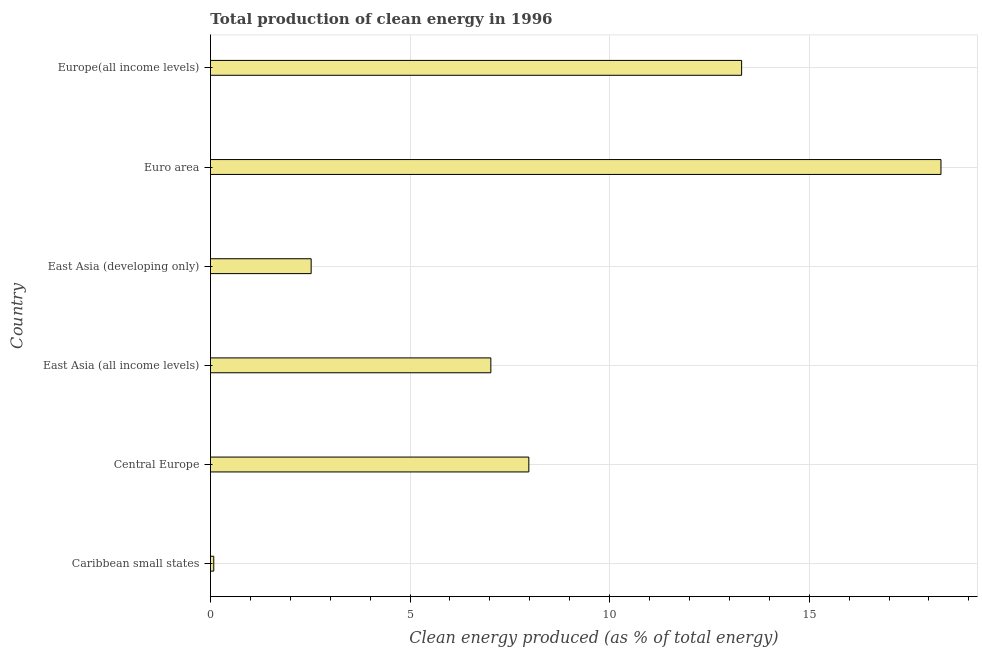Does the graph contain grids?
Offer a terse response. Yes. What is the title of the graph?
Provide a succinct answer. Total production of clean energy in 1996. What is the label or title of the X-axis?
Ensure brevity in your answer.  Clean energy produced (as % of total energy). What is the label or title of the Y-axis?
Provide a succinct answer. Country. What is the production of clean energy in East Asia (all income levels)?
Give a very brief answer. 7.02. Across all countries, what is the maximum production of clean energy?
Your answer should be compact. 18.3. Across all countries, what is the minimum production of clean energy?
Make the answer very short. 0.08. In which country was the production of clean energy maximum?
Give a very brief answer. Euro area. In which country was the production of clean energy minimum?
Offer a very short reply. Caribbean small states. What is the sum of the production of clean energy?
Your answer should be compact. 49.21. What is the difference between the production of clean energy in Caribbean small states and East Asia (developing only)?
Your response must be concise. -2.44. What is the average production of clean energy per country?
Provide a short and direct response. 8.2. What is the median production of clean energy?
Provide a short and direct response. 7.5. What is the ratio of the production of clean energy in Caribbean small states to that in East Asia (all income levels)?
Provide a short and direct response. 0.01. Is the difference between the production of clean energy in East Asia (all income levels) and East Asia (developing only) greater than the difference between any two countries?
Make the answer very short. No. What is the difference between the highest and the second highest production of clean energy?
Make the answer very short. 4.99. Is the sum of the production of clean energy in Central Europe and East Asia (developing only) greater than the maximum production of clean energy across all countries?
Keep it short and to the point. No. What is the difference between the highest and the lowest production of clean energy?
Make the answer very short. 18.22. In how many countries, is the production of clean energy greater than the average production of clean energy taken over all countries?
Your answer should be very brief. 2. How many bars are there?
Keep it short and to the point. 6. Are the values on the major ticks of X-axis written in scientific E-notation?
Your answer should be compact. No. What is the Clean energy produced (as % of total energy) of Caribbean small states?
Give a very brief answer. 0.08. What is the Clean energy produced (as % of total energy) in Central Europe?
Make the answer very short. 7.98. What is the Clean energy produced (as % of total energy) in East Asia (all income levels)?
Your answer should be very brief. 7.02. What is the Clean energy produced (as % of total energy) of East Asia (developing only)?
Give a very brief answer. 2.52. What is the Clean energy produced (as % of total energy) of Euro area?
Provide a short and direct response. 18.3. What is the Clean energy produced (as % of total energy) in Europe(all income levels)?
Make the answer very short. 13.31. What is the difference between the Clean energy produced (as % of total energy) in Caribbean small states and Central Europe?
Make the answer very short. -7.89. What is the difference between the Clean energy produced (as % of total energy) in Caribbean small states and East Asia (all income levels)?
Your answer should be very brief. -6.94. What is the difference between the Clean energy produced (as % of total energy) in Caribbean small states and East Asia (developing only)?
Offer a terse response. -2.44. What is the difference between the Clean energy produced (as % of total energy) in Caribbean small states and Euro area?
Keep it short and to the point. -18.22. What is the difference between the Clean energy produced (as % of total energy) in Caribbean small states and Europe(all income levels)?
Your response must be concise. -13.22. What is the difference between the Clean energy produced (as % of total energy) in Central Europe and East Asia (all income levels)?
Ensure brevity in your answer.  0.95. What is the difference between the Clean energy produced (as % of total energy) in Central Europe and East Asia (developing only)?
Keep it short and to the point. 5.45. What is the difference between the Clean energy produced (as % of total energy) in Central Europe and Euro area?
Make the answer very short. -10.33. What is the difference between the Clean energy produced (as % of total energy) in Central Europe and Europe(all income levels)?
Offer a terse response. -5.33. What is the difference between the Clean energy produced (as % of total energy) in East Asia (all income levels) and East Asia (developing only)?
Your answer should be compact. 4.5. What is the difference between the Clean energy produced (as % of total energy) in East Asia (all income levels) and Euro area?
Your response must be concise. -11.28. What is the difference between the Clean energy produced (as % of total energy) in East Asia (all income levels) and Europe(all income levels)?
Your response must be concise. -6.28. What is the difference between the Clean energy produced (as % of total energy) in East Asia (developing only) and Euro area?
Your answer should be very brief. -15.78. What is the difference between the Clean energy produced (as % of total energy) in East Asia (developing only) and Europe(all income levels)?
Provide a short and direct response. -10.78. What is the difference between the Clean energy produced (as % of total energy) in Euro area and Europe(all income levels)?
Keep it short and to the point. 4.99. What is the ratio of the Clean energy produced (as % of total energy) in Caribbean small states to that in East Asia (all income levels)?
Provide a succinct answer. 0.01. What is the ratio of the Clean energy produced (as % of total energy) in Caribbean small states to that in East Asia (developing only)?
Ensure brevity in your answer.  0.03. What is the ratio of the Clean energy produced (as % of total energy) in Caribbean small states to that in Euro area?
Keep it short and to the point. 0.01. What is the ratio of the Clean energy produced (as % of total energy) in Caribbean small states to that in Europe(all income levels)?
Give a very brief answer. 0.01. What is the ratio of the Clean energy produced (as % of total energy) in Central Europe to that in East Asia (all income levels)?
Provide a succinct answer. 1.14. What is the ratio of the Clean energy produced (as % of total energy) in Central Europe to that in East Asia (developing only)?
Make the answer very short. 3.16. What is the ratio of the Clean energy produced (as % of total energy) in Central Europe to that in Euro area?
Offer a very short reply. 0.44. What is the ratio of the Clean energy produced (as % of total energy) in Central Europe to that in Europe(all income levels)?
Give a very brief answer. 0.6. What is the ratio of the Clean energy produced (as % of total energy) in East Asia (all income levels) to that in East Asia (developing only)?
Your response must be concise. 2.79. What is the ratio of the Clean energy produced (as % of total energy) in East Asia (all income levels) to that in Euro area?
Your response must be concise. 0.38. What is the ratio of the Clean energy produced (as % of total energy) in East Asia (all income levels) to that in Europe(all income levels)?
Offer a very short reply. 0.53. What is the ratio of the Clean energy produced (as % of total energy) in East Asia (developing only) to that in Euro area?
Keep it short and to the point. 0.14. What is the ratio of the Clean energy produced (as % of total energy) in East Asia (developing only) to that in Europe(all income levels)?
Provide a succinct answer. 0.19. What is the ratio of the Clean energy produced (as % of total energy) in Euro area to that in Europe(all income levels)?
Make the answer very short. 1.38. 